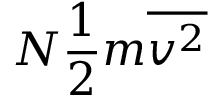<formula> <loc_0><loc_0><loc_500><loc_500>N { \frac { 1 } { 2 } } m { \overline { { v ^ { 2 } } } }</formula> 